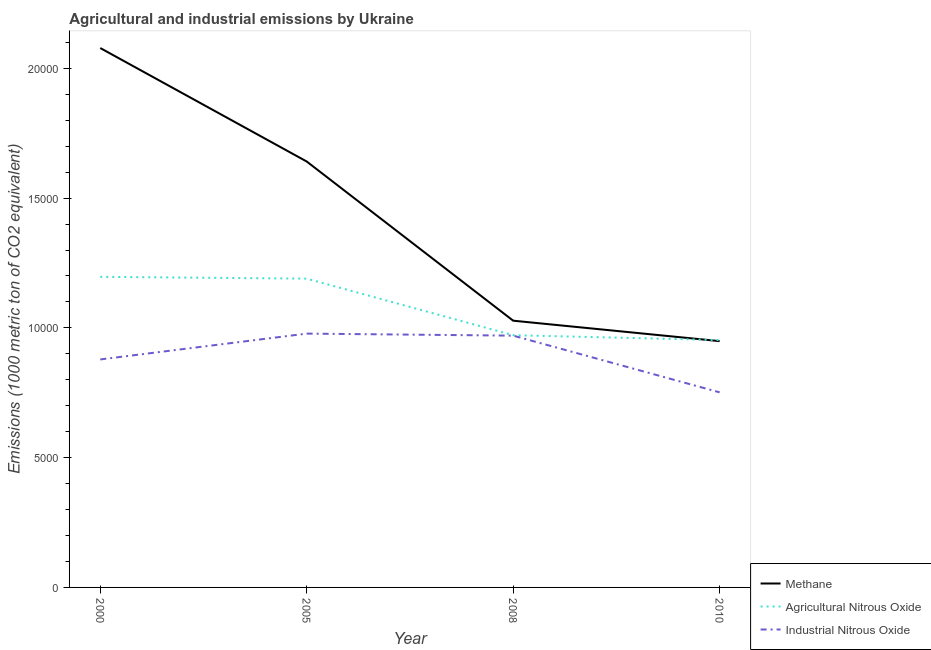Does the line corresponding to amount of industrial nitrous oxide emissions intersect with the line corresponding to amount of agricultural nitrous oxide emissions?
Your answer should be very brief. No. What is the amount of methane emissions in 2010?
Offer a very short reply. 9489.8. Across all years, what is the maximum amount of agricultural nitrous oxide emissions?
Your answer should be compact. 1.20e+04. Across all years, what is the minimum amount of methane emissions?
Offer a terse response. 9489.8. In which year was the amount of methane emissions minimum?
Provide a short and direct response. 2010. What is the total amount of agricultural nitrous oxide emissions in the graph?
Make the answer very short. 4.31e+04. What is the difference between the amount of methane emissions in 2008 and that in 2010?
Make the answer very short. 788.2. What is the difference between the amount of agricultural nitrous oxide emissions in 2010 and the amount of methane emissions in 2005?
Give a very brief answer. -6880. What is the average amount of industrial nitrous oxide emissions per year?
Keep it short and to the point. 8945.85. In the year 2008, what is the difference between the amount of methane emissions and amount of industrial nitrous oxide emissions?
Keep it short and to the point. 576.2. What is the ratio of the amount of methane emissions in 2000 to that in 2010?
Give a very brief answer. 2.19. Is the amount of industrial nitrous oxide emissions in 2008 less than that in 2010?
Offer a terse response. No. Is the difference between the amount of methane emissions in 2005 and 2008 greater than the difference between the amount of industrial nitrous oxide emissions in 2005 and 2008?
Offer a terse response. Yes. What is the difference between the highest and the second highest amount of methane emissions?
Provide a succinct answer. 4372.1. What is the difference between the highest and the lowest amount of industrial nitrous oxide emissions?
Ensure brevity in your answer.  2263. In how many years, is the amount of industrial nitrous oxide emissions greater than the average amount of industrial nitrous oxide emissions taken over all years?
Keep it short and to the point. 2. Does the amount of methane emissions monotonically increase over the years?
Give a very brief answer. No. Is the amount of agricultural nitrous oxide emissions strictly greater than the amount of methane emissions over the years?
Provide a succinct answer. No. Is the amount of methane emissions strictly less than the amount of industrial nitrous oxide emissions over the years?
Offer a very short reply. No. How many years are there in the graph?
Give a very brief answer. 4. What is the difference between two consecutive major ticks on the Y-axis?
Your response must be concise. 5000. Are the values on the major ticks of Y-axis written in scientific E-notation?
Provide a short and direct response. No. Where does the legend appear in the graph?
Keep it short and to the point. Bottom right. How many legend labels are there?
Your answer should be very brief. 3. What is the title of the graph?
Your response must be concise. Agricultural and industrial emissions by Ukraine. What is the label or title of the X-axis?
Your answer should be very brief. Year. What is the label or title of the Y-axis?
Provide a succinct answer. Emissions (1000 metric ton of CO2 equivalent). What is the Emissions (1000 metric ton of CO2 equivalent) in Methane in 2000?
Provide a short and direct response. 2.08e+04. What is the Emissions (1000 metric ton of CO2 equivalent) of Agricultural Nitrous Oxide in 2000?
Keep it short and to the point. 1.20e+04. What is the Emissions (1000 metric ton of CO2 equivalent) of Industrial Nitrous Oxide in 2000?
Your response must be concise. 8784.8. What is the Emissions (1000 metric ton of CO2 equivalent) in Methane in 2005?
Ensure brevity in your answer.  1.64e+04. What is the Emissions (1000 metric ton of CO2 equivalent) in Agricultural Nitrous Oxide in 2005?
Provide a short and direct response. 1.19e+04. What is the Emissions (1000 metric ton of CO2 equivalent) in Industrial Nitrous Oxide in 2005?
Your response must be concise. 9779.9. What is the Emissions (1000 metric ton of CO2 equivalent) in Methane in 2008?
Make the answer very short. 1.03e+04. What is the Emissions (1000 metric ton of CO2 equivalent) in Agricultural Nitrous Oxide in 2008?
Provide a short and direct response. 9719.1. What is the Emissions (1000 metric ton of CO2 equivalent) of Industrial Nitrous Oxide in 2008?
Keep it short and to the point. 9701.8. What is the Emissions (1000 metric ton of CO2 equivalent) in Methane in 2010?
Your answer should be compact. 9489.8. What is the Emissions (1000 metric ton of CO2 equivalent) of Agricultural Nitrous Oxide in 2010?
Provide a succinct answer. 9531.4. What is the Emissions (1000 metric ton of CO2 equivalent) in Industrial Nitrous Oxide in 2010?
Your answer should be very brief. 7516.9. Across all years, what is the maximum Emissions (1000 metric ton of CO2 equivalent) in Methane?
Give a very brief answer. 2.08e+04. Across all years, what is the maximum Emissions (1000 metric ton of CO2 equivalent) of Agricultural Nitrous Oxide?
Offer a terse response. 1.20e+04. Across all years, what is the maximum Emissions (1000 metric ton of CO2 equivalent) in Industrial Nitrous Oxide?
Keep it short and to the point. 9779.9. Across all years, what is the minimum Emissions (1000 metric ton of CO2 equivalent) of Methane?
Provide a short and direct response. 9489.8. Across all years, what is the minimum Emissions (1000 metric ton of CO2 equivalent) in Agricultural Nitrous Oxide?
Your answer should be compact. 9531.4. Across all years, what is the minimum Emissions (1000 metric ton of CO2 equivalent) of Industrial Nitrous Oxide?
Give a very brief answer. 7516.9. What is the total Emissions (1000 metric ton of CO2 equivalent) of Methane in the graph?
Your answer should be compact. 5.70e+04. What is the total Emissions (1000 metric ton of CO2 equivalent) in Agricultural Nitrous Oxide in the graph?
Your response must be concise. 4.31e+04. What is the total Emissions (1000 metric ton of CO2 equivalent) in Industrial Nitrous Oxide in the graph?
Give a very brief answer. 3.58e+04. What is the difference between the Emissions (1000 metric ton of CO2 equivalent) in Methane in 2000 and that in 2005?
Give a very brief answer. 4372.1. What is the difference between the Emissions (1000 metric ton of CO2 equivalent) of Agricultural Nitrous Oxide in 2000 and that in 2005?
Keep it short and to the point. 70.4. What is the difference between the Emissions (1000 metric ton of CO2 equivalent) of Industrial Nitrous Oxide in 2000 and that in 2005?
Your response must be concise. -995.1. What is the difference between the Emissions (1000 metric ton of CO2 equivalent) in Methane in 2000 and that in 2008?
Keep it short and to the point. 1.05e+04. What is the difference between the Emissions (1000 metric ton of CO2 equivalent) in Agricultural Nitrous Oxide in 2000 and that in 2008?
Your response must be concise. 2248.8. What is the difference between the Emissions (1000 metric ton of CO2 equivalent) in Industrial Nitrous Oxide in 2000 and that in 2008?
Your answer should be very brief. -917. What is the difference between the Emissions (1000 metric ton of CO2 equivalent) of Methane in 2000 and that in 2010?
Give a very brief answer. 1.13e+04. What is the difference between the Emissions (1000 metric ton of CO2 equivalent) in Agricultural Nitrous Oxide in 2000 and that in 2010?
Give a very brief answer. 2436.5. What is the difference between the Emissions (1000 metric ton of CO2 equivalent) in Industrial Nitrous Oxide in 2000 and that in 2010?
Your answer should be compact. 1267.9. What is the difference between the Emissions (1000 metric ton of CO2 equivalent) in Methane in 2005 and that in 2008?
Make the answer very short. 6133.4. What is the difference between the Emissions (1000 metric ton of CO2 equivalent) in Agricultural Nitrous Oxide in 2005 and that in 2008?
Ensure brevity in your answer.  2178.4. What is the difference between the Emissions (1000 metric ton of CO2 equivalent) in Industrial Nitrous Oxide in 2005 and that in 2008?
Offer a terse response. 78.1. What is the difference between the Emissions (1000 metric ton of CO2 equivalent) of Methane in 2005 and that in 2010?
Provide a succinct answer. 6921.6. What is the difference between the Emissions (1000 metric ton of CO2 equivalent) of Agricultural Nitrous Oxide in 2005 and that in 2010?
Your response must be concise. 2366.1. What is the difference between the Emissions (1000 metric ton of CO2 equivalent) of Industrial Nitrous Oxide in 2005 and that in 2010?
Make the answer very short. 2263. What is the difference between the Emissions (1000 metric ton of CO2 equivalent) of Methane in 2008 and that in 2010?
Make the answer very short. 788.2. What is the difference between the Emissions (1000 metric ton of CO2 equivalent) in Agricultural Nitrous Oxide in 2008 and that in 2010?
Provide a succinct answer. 187.7. What is the difference between the Emissions (1000 metric ton of CO2 equivalent) of Industrial Nitrous Oxide in 2008 and that in 2010?
Provide a succinct answer. 2184.9. What is the difference between the Emissions (1000 metric ton of CO2 equivalent) of Methane in 2000 and the Emissions (1000 metric ton of CO2 equivalent) of Agricultural Nitrous Oxide in 2005?
Keep it short and to the point. 8886. What is the difference between the Emissions (1000 metric ton of CO2 equivalent) of Methane in 2000 and the Emissions (1000 metric ton of CO2 equivalent) of Industrial Nitrous Oxide in 2005?
Your answer should be very brief. 1.10e+04. What is the difference between the Emissions (1000 metric ton of CO2 equivalent) in Agricultural Nitrous Oxide in 2000 and the Emissions (1000 metric ton of CO2 equivalent) in Industrial Nitrous Oxide in 2005?
Keep it short and to the point. 2188. What is the difference between the Emissions (1000 metric ton of CO2 equivalent) in Methane in 2000 and the Emissions (1000 metric ton of CO2 equivalent) in Agricultural Nitrous Oxide in 2008?
Offer a terse response. 1.11e+04. What is the difference between the Emissions (1000 metric ton of CO2 equivalent) of Methane in 2000 and the Emissions (1000 metric ton of CO2 equivalent) of Industrial Nitrous Oxide in 2008?
Keep it short and to the point. 1.11e+04. What is the difference between the Emissions (1000 metric ton of CO2 equivalent) of Agricultural Nitrous Oxide in 2000 and the Emissions (1000 metric ton of CO2 equivalent) of Industrial Nitrous Oxide in 2008?
Provide a short and direct response. 2266.1. What is the difference between the Emissions (1000 metric ton of CO2 equivalent) of Methane in 2000 and the Emissions (1000 metric ton of CO2 equivalent) of Agricultural Nitrous Oxide in 2010?
Your response must be concise. 1.13e+04. What is the difference between the Emissions (1000 metric ton of CO2 equivalent) in Methane in 2000 and the Emissions (1000 metric ton of CO2 equivalent) in Industrial Nitrous Oxide in 2010?
Make the answer very short. 1.33e+04. What is the difference between the Emissions (1000 metric ton of CO2 equivalent) of Agricultural Nitrous Oxide in 2000 and the Emissions (1000 metric ton of CO2 equivalent) of Industrial Nitrous Oxide in 2010?
Your answer should be very brief. 4451. What is the difference between the Emissions (1000 metric ton of CO2 equivalent) of Methane in 2005 and the Emissions (1000 metric ton of CO2 equivalent) of Agricultural Nitrous Oxide in 2008?
Make the answer very short. 6692.3. What is the difference between the Emissions (1000 metric ton of CO2 equivalent) of Methane in 2005 and the Emissions (1000 metric ton of CO2 equivalent) of Industrial Nitrous Oxide in 2008?
Ensure brevity in your answer.  6709.6. What is the difference between the Emissions (1000 metric ton of CO2 equivalent) of Agricultural Nitrous Oxide in 2005 and the Emissions (1000 metric ton of CO2 equivalent) of Industrial Nitrous Oxide in 2008?
Your answer should be very brief. 2195.7. What is the difference between the Emissions (1000 metric ton of CO2 equivalent) in Methane in 2005 and the Emissions (1000 metric ton of CO2 equivalent) in Agricultural Nitrous Oxide in 2010?
Keep it short and to the point. 6880. What is the difference between the Emissions (1000 metric ton of CO2 equivalent) in Methane in 2005 and the Emissions (1000 metric ton of CO2 equivalent) in Industrial Nitrous Oxide in 2010?
Provide a short and direct response. 8894.5. What is the difference between the Emissions (1000 metric ton of CO2 equivalent) in Agricultural Nitrous Oxide in 2005 and the Emissions (1000 metric ton of CO2 equivalent) in Industrial Nitrous Oxide in 2010?
Keep it short and to the point. 4380.6. What is the difference between the Emissions (1000 metric ton of CO2 equivalent) in Methane in 2008 and the Emissions (1000 metric ton of CO2 equivalent) in Agricultural Nitrous Oxide in 2010?
Keep it short and to the point. 746.6. What is the difference between the Emissions (1000 metric ton of CO2 equivalent) in Methane in 2008 and the Emissions (1000 metric ton of CO2 equivalent) in Industrial Nitrous Oxide in 2010?
Give a very brief answer. 2761.1. What is the difference between the Emissions (1000 metric ton of CO2 equivalent) of Agricultural Nitrous Oxide in 2008 and the Emissions (1000 metric ton of CO2 equivalent) of Industrial Nitrous Oxide in 2010?
Your answer should be compact. 2202.2. What is the average Emissions (1000 metric ton of CO2 equivalent) in Methane per year?
Make the answer very short. 1.42e+04. What is the average Emissions (1000 metric ton of CO2 equivalent) of Agricultural Nitrous Oxide per year?
Keep it short and to the point. 1.08e+04. What is the average Emissions (1000 metric ton of CO2 equivalent) in Industrial Nitrous Oxide per year?
Make the answer very short. 8945.85. In the year 2000, what is the difference between the Emissions (1000 metric ton of CO2 equivalent) in Methane and Emissions (1000 metric ton of CO2 equivalent) in Agricultural Nitrous Oxide?
Make the answer very short. 8815.6. In the year 2000, what is the difference between the Emissions (1000 metric ton of CO2 equivalent) of Methane and Emissions (1000 metric ton of CO2 equivalent) of Industrial Nitrous Oxide?
Offer a terse response. 1.20e+04. In the year 2000, what is the difference between the Emissions (1000 metric ton of CO2 equivalent) in Agricultural Nitrous Oxide and Emissions (1000 metric ton of CO2 equivalent) in Industrial Nitrous Oxide?
Your answer should be compact. 3183.1. In the year 2005, what is the difference between the Emissions (1000 metric ton of CO2 equivalent) in Methane and Emissions (1000 metric ton of CO2 equivalent) in Agricultural Nitrous Oxide?
Your answer should be compact. 4513.9. In the year 2005, what is the difference between the Emissions (1000 metric ton of CO2 equivalent) in Methane and Emissions (1000 metric ton of CO2 equivalent) in Industrial Nitrous Oxide?
Provide a short and direct response. 6631.5. In the year 2005, what is the difference between the Emissions (1000 metric ton of CO2 equivalent) in Agricultural Nitrous Oxide and Emissions (1000 metric ton of CO2 equivalent) in Industrial Nitrous Oxide?
Your answer should be very brief. 2117.6. In the year 2008, what is the difference between the Emissions (1000 metric ton of CO2 equivalent) of Methane and Emissions (1000 metric ton of CO2 equivalent) of Agricultural Nitrous Oxide?
Your answer should be very brief. 558.9. In the year 2008, what is the difference between the Emissions (1000 metric ton of CO2 equivalent) of Methane and Emissions (1000 metric ton of CO2 equivalent) of Industrial Nitrous Oxide?
Offer a very short reply. 576.2. In the year 2008, what is the difference between the Emissions (1000 metric ton of CO2 equivalent) of Agricultural Nitrous Oxide and Emissions (1000 metric ton of CO2 equivalent) of Industrial Nitrous Oxide?
Provide a succinct answer. 17.3. In the year 2010, what is the difference between the Emissions (1000 metric ton of CO2 equivalent) of Methane and Emissions (1000 metric ton of CO2 equivalent) of Agricultural Nitrous Oxide?
Ensure brevity in your answer.  -41.6. In the year 2010, what is the difference between the Emissions (1000 metric ton of CO2 equivalent) of Methane and Emissions (1000 metric ton of CO2 equivalent) of Industrial Nitrous Oxide?
Keep it short and to the point. 1972.9. In the year 2010, what is the difference between the Emissions (1000 metric ton of CO2 equivalent) in Agricultural Nitrous Oxide and Emissions (1000 metric ton of CO2 equivalent) in Industrial Nitrous Oxide?
Offer a terse response. 2014.5. What is the ratio of the Emissions (1000 metric ton of CO2 equivalent) of Methane in 2000 to that in 2005?
Offer a terse response. 1.27. What is the ratio of the Emissions (1000 metric ton of CO2 equivalent) of Agricultural Nitrous Oxide in 2000 to that in 2005?
Make the answer very short. 1.01. What is the ratio of the Emissions (1000 metric ton of CO2 equivalent) in Industrial Nitrous Oxide in 2000 to that in 2005?
Ensure brevity in your answer.  0.9. What is the ratio of the Emissions (1000 metric ton of CO2 equivalent) in Methane in 2000 to that in 2008?
Keep it short and to the point. 2.02. What is the ratio of the Emissions (1000 metric ton of CO2 equivalent) in Agricultural Nitrous Oxide in 2000 to that in 2008?
Your response must be concise. 1.23. What is the ratio of the Emissions (1000 metric ton of CO2 equivalent) in Industrial Nitrous Oxide in 2000 to that in 2008?
Your response must be concise. 0.91. What is the ratio of the Emissions (1000 metric ton of CO2 equivalent) in Methane in 2000 to that in 2010?
Your answer should be very brief. 2.19. What is the ratio of the Emissions (1000 metric ton of CO2 equivalent) of Agricultural Nitrous Oxide in 2000 to that in 2010?
Make the answer very short. 1.26. What is the ratio of the Emissions (1000 metric ton of CO2 equivalent) in Industrial Nitrous Oxide in 2000 to that in 2010?
Your answer should be very brief. 1.17. What is the ratio of the Emissions (1000 metric ton of CO2 equivalent) in Methane in 2005 to that in 2008?
Give a very brief answer. 1.6. What is the ratio of the Emissions (1000 metric ton of CO2 equivalent) of Agricultural Nitrous Oxide in 2005 to that in 2008?
Your answer should be very brief. 1.22. What is the ratio of the Emissions (1000 metric ton of CO2 equivalent) of Industrial Nitrous Oxide in 2005 to that in 2008?
Your answer should be compact. 1.01. What is the ratio of the Emissions (1000 metric ton of CO2 equivalent) in Methane in 2005 to that in 2010?
Ensure brevity in your answer.  1.73. What is the ratio of the Emissions (1000 metric ton of CO2 equivalent) of Agricultural Nitrous Oxide in 2005 to that in 2010?
Your response must be concise. 1.25. What is the ratio of the Emissions (1000 metric ton of CO2 equivalent) in Industrial Nitrous Oxide in 2005 to that in 2010?
Offer a terse response. 1.3. What is the ratio of the Emissions (1000 metric ton of CO2 equivalent) of Methane in 2008 to that in 2010?
Offer a terse response. 1.08. What is the ratio of the Emissions (1000 metric ton of CO2 equivalent) of Agricultural Nitrous Oxide in 2008 to that in 2010?
Give a very brief answer. 1.02. What is the ratio of the Emissions (1000 metric ton of CO2 equivalent) of Industrial Nitrous Oxide in 2008 to that in 2010?
Offer a terse response. 1.29. What is the difference between the highest and the second highest Emissions (1000 metric ton of CO2 equivalent) in Methane?
Offer a terse response. 4372.1. What is the difference between the highest and the second highest Emissions (1000 metric ton of CO2 equivalent) in Agricultural Nitrous Oxide?
Your answer should be very brief. 70.4. What is the difference between the highest and the second highest Emissions (1000 metric ton of CO2 equivalent) of Industrial Nitrous Oxide?
Provide a succinct answer. 78.1. What is the difference between the highest and the lowest Emissions (1000 metric ton of CO2 equivalent) in Methane?
Your response must be concise. 1.13e+04. What is the difference between the highest and the lowest Emissions (1000 metric ton of CO2 equivalent) in Agricultural Nitrous Oxide?
Offer a terse response. 2436.5. What is the difference between the highest and the lowest Emissions (1000 metric ton of CO2 equivalent) of Industrial Nitrous Oxide?
Ensure brevity in your answer.  2263. 